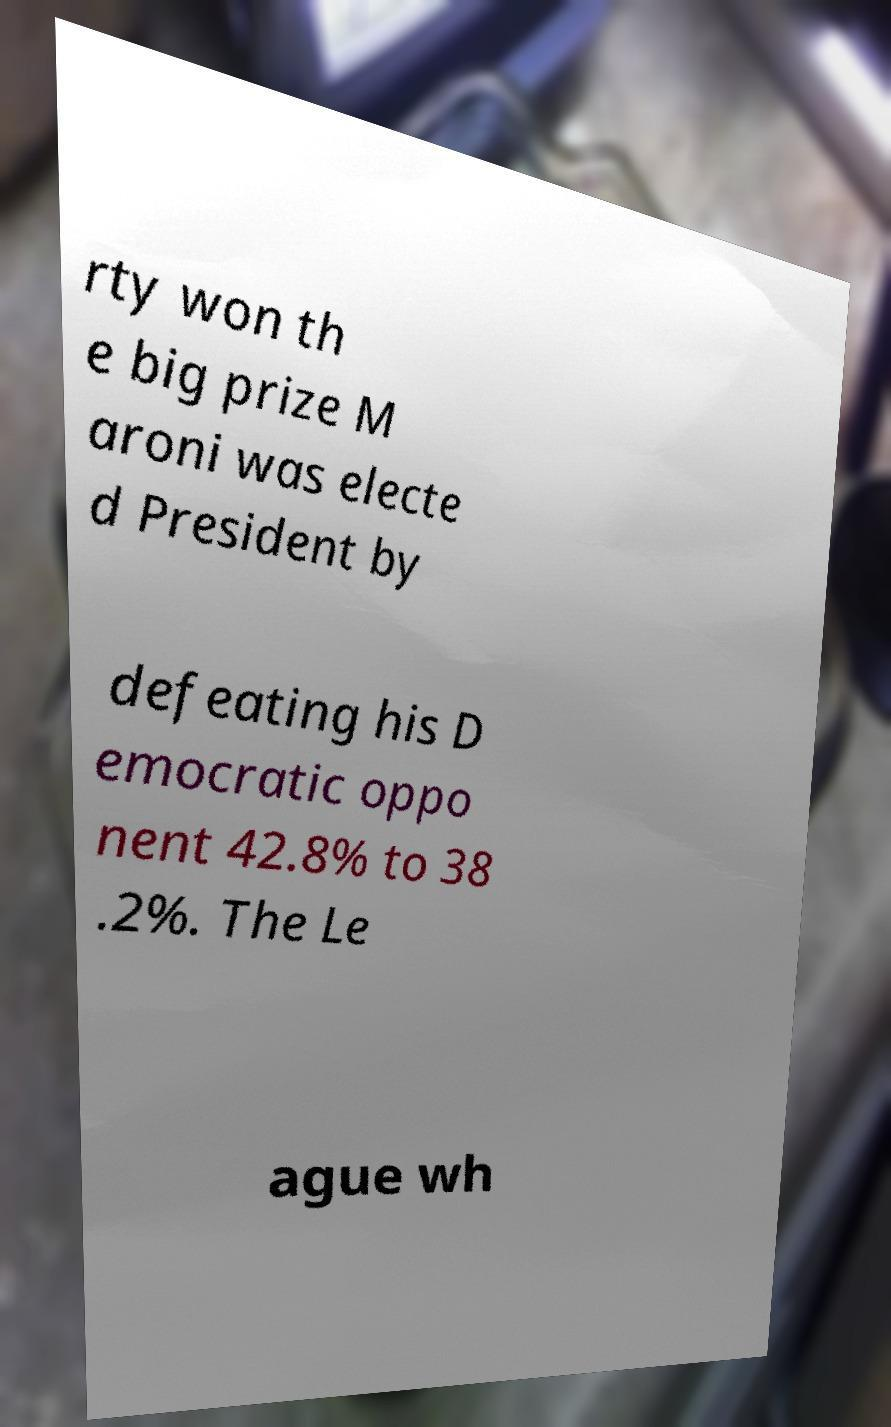For documentation purposes, I need the text within this image transcribed. Could you provide that? rty won th e big prize M aroni was electe d President by defeating his D emocratic oppo nent 42.8% to 38 .2%. The Le ague wh 